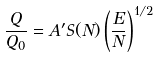<formula> <loc_0><loc_0><loc_500><loc_500>\frac { Q } { Q _ { 0 } } = A ^ { \prime } S ( N ) \left ( \frac { E } { N } \right ) ^ { 1 / 2 }</formula> 